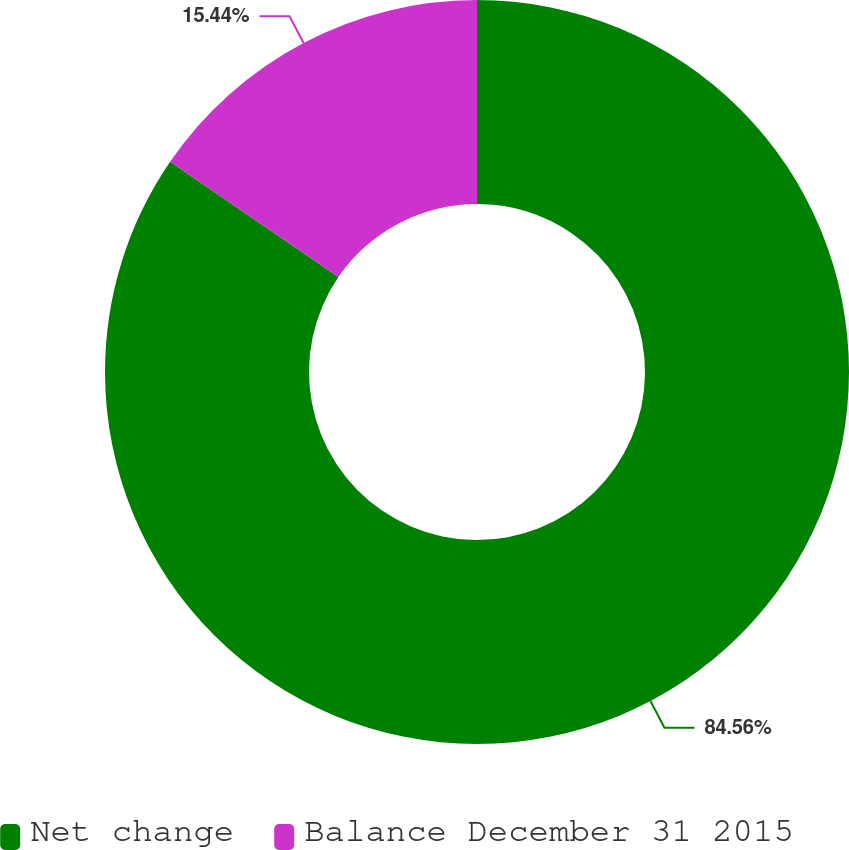Convert chart. <chart><loc_0><loc_0><loc_500><loc_500><pie_chart><fcel>Net change<fcel>Balance December 31 2015<nl><fcel>84.56%<fcel>15.44%<nl></chart> 